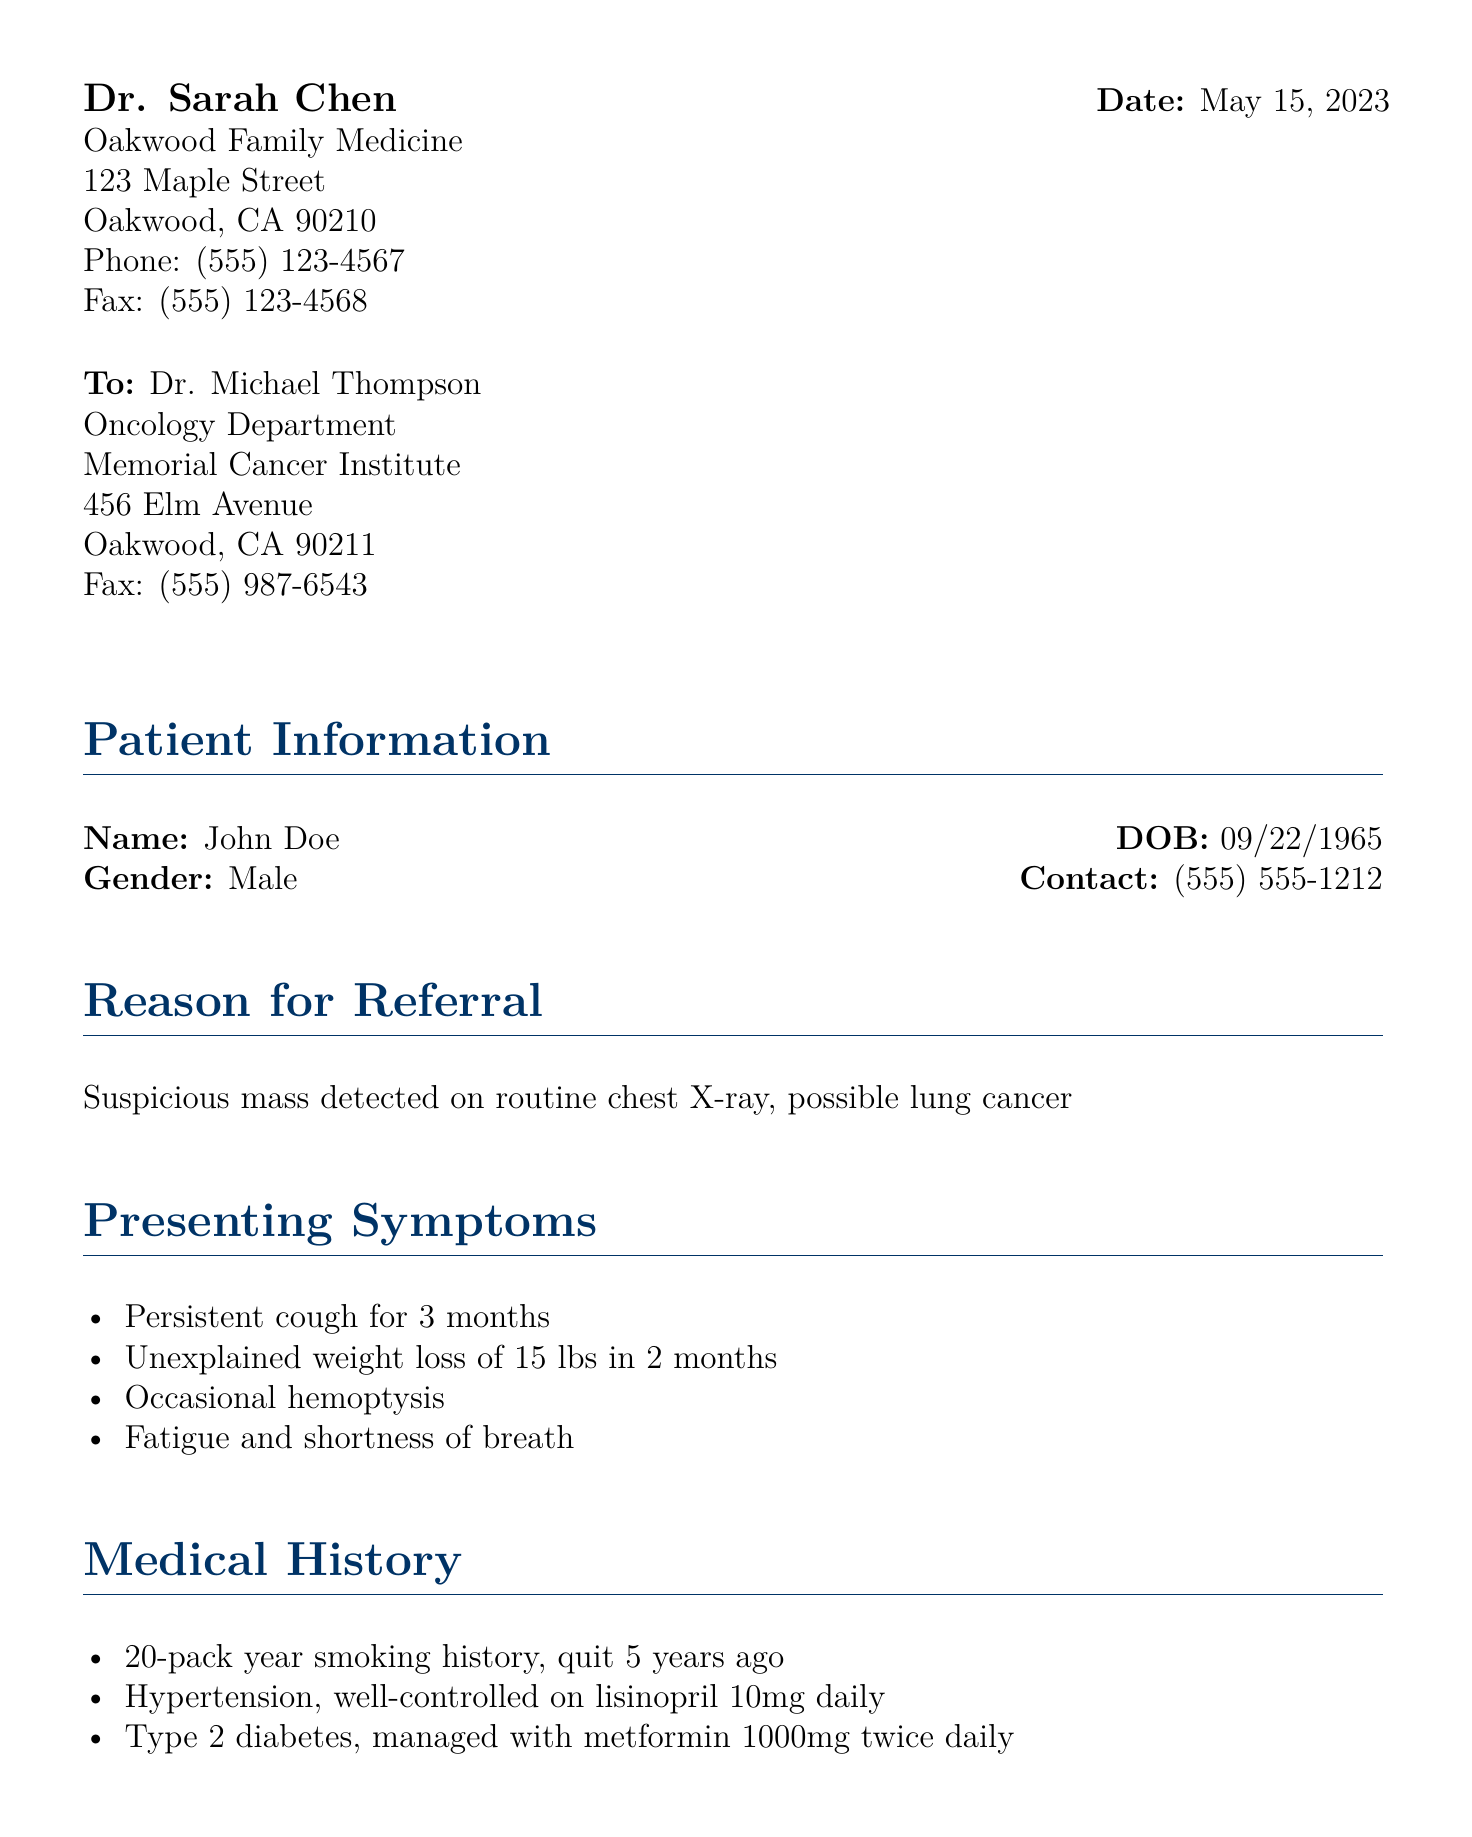What is the patient's name? The patient's name is mentioned in the document under the patient information section.
Answer: John Doe What is the patient's date of birth? The date of birth is explicitly listed next to the patient's name in the document.
Answer: 09/22/1965 What was detected on the routine chest X-ray? This information is stated in the reason for referral section of the document.
Answer: Suspicious mass What are two presenting symptoms of the patient? The presenting symptoms are listed in a bulleted format.
Answer: Persistent cough, unexplained weight loss What is the patient's smoking history? The smoking history is described in detail under the medical history section.
Answer: 20-pack year smoking history, quit 5 years ago Who is the referring physician? The name of the referring physician is found at the beginning of the document.
Answer: Dr. Sarah Chen What medication is the patient taking for hypertension? The medication is mentioned in the medical history section that lists the patient's medications.
Answer: Lisinopril What family history is noted in the document? Family history is summarized in a separate section and provides information about the patient's father.
Answer: Father died of lung cancer at age 62 What is the request made by the referring physician? The request is clearly stated near the end of the document.
Answer: Evaluate for possible lung malignancy 